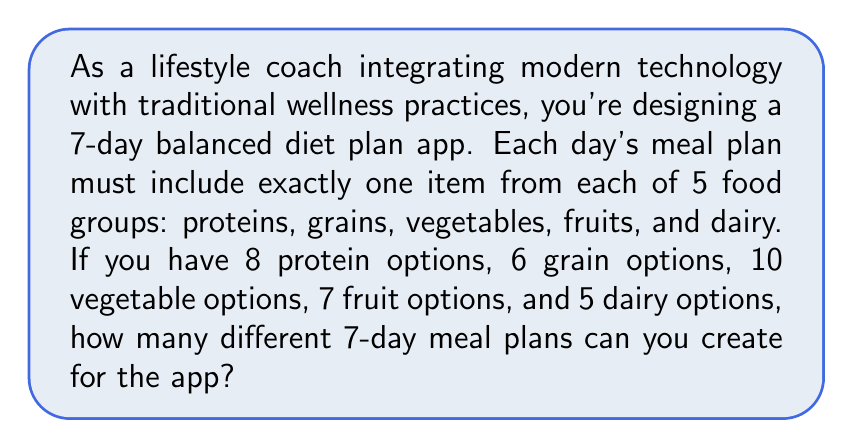Could you help me with this problem? Let's break this down step-by-step:

1) For each day, we need to choose one item from each food group. This is a combination problem.

2) For a single day, the number of possible meal combinations is:
   $8 \times 6 \times 10 \times 7 \times 5 = 16,800$

3) We need to create this combination for 7 days. Since the choices for each day are independent, we use the multiplication principle.

4) The total number of possible 7-day meal plans is:
   $$(16,800)^7$$

5) Let's calculate this:
   $16,800^7 = 6.4988 \times 10^{30}$

6) This can also be written as:
   $$8^7 \times 6^7 \times 10^7 \times 7^7 \times 5^7$$

7) Which equals:
   $$2,097,152 \times 279,936 \times 10,000,000 \times 823,543 \times 78,125$$

8) The final result is a very large number:
   $$649,877,898,752,000,000,000,000,000,000$$
Answer: $649,877,898,752,000,000,000,000,000,000$ 